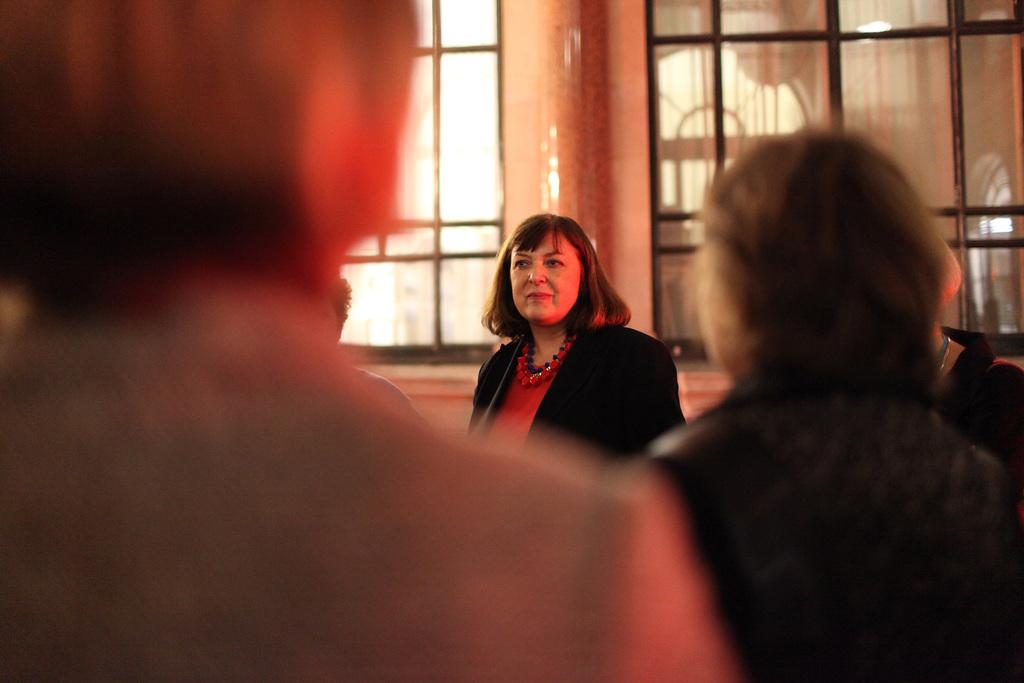How many people are standing behind others in the image? There are four people standing behind other people in the image. What type of material can be seen in the image? There are glass windows in the image. What is on the floor in the image? There is a mat in the image. Can you describe the clothing of one of the people in the image? There is a woman wearing a black jacket in the image. What type of tax is being discussed in the image? There is no discussion of tax in the image. Can you see a brush in the image? There is no brush present in the image. 